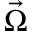Convert formula to latex. <formula><loc_0><loc_0><loc_500><loc_500>\vec { \Omega }</formula> 